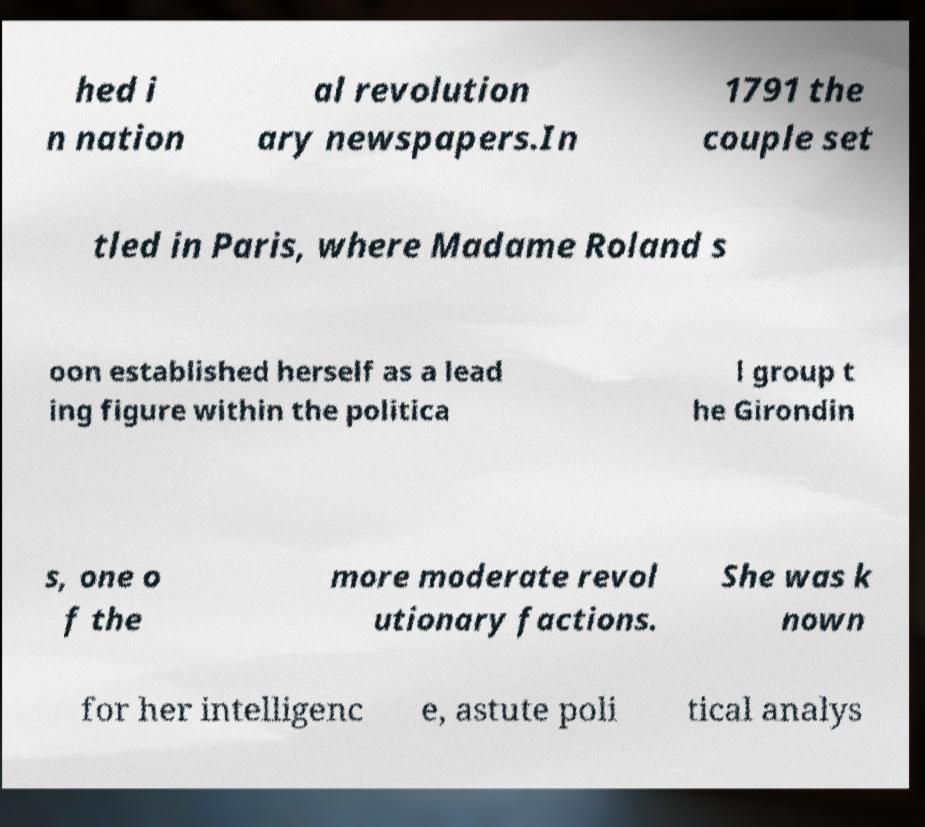There's text embedded in this image that I need extracted. Can you transcribe it verbatim? hed i n nation al revolution ary newspapers.In 1791 the couple set tled in Paris, where Madame Roland s oon established herself as a lead ing figure within the politica l group t he Girondin s, one o f the more moderate revol utionary factions. She was k nown for her intelligenc e, astute poli tical analys 